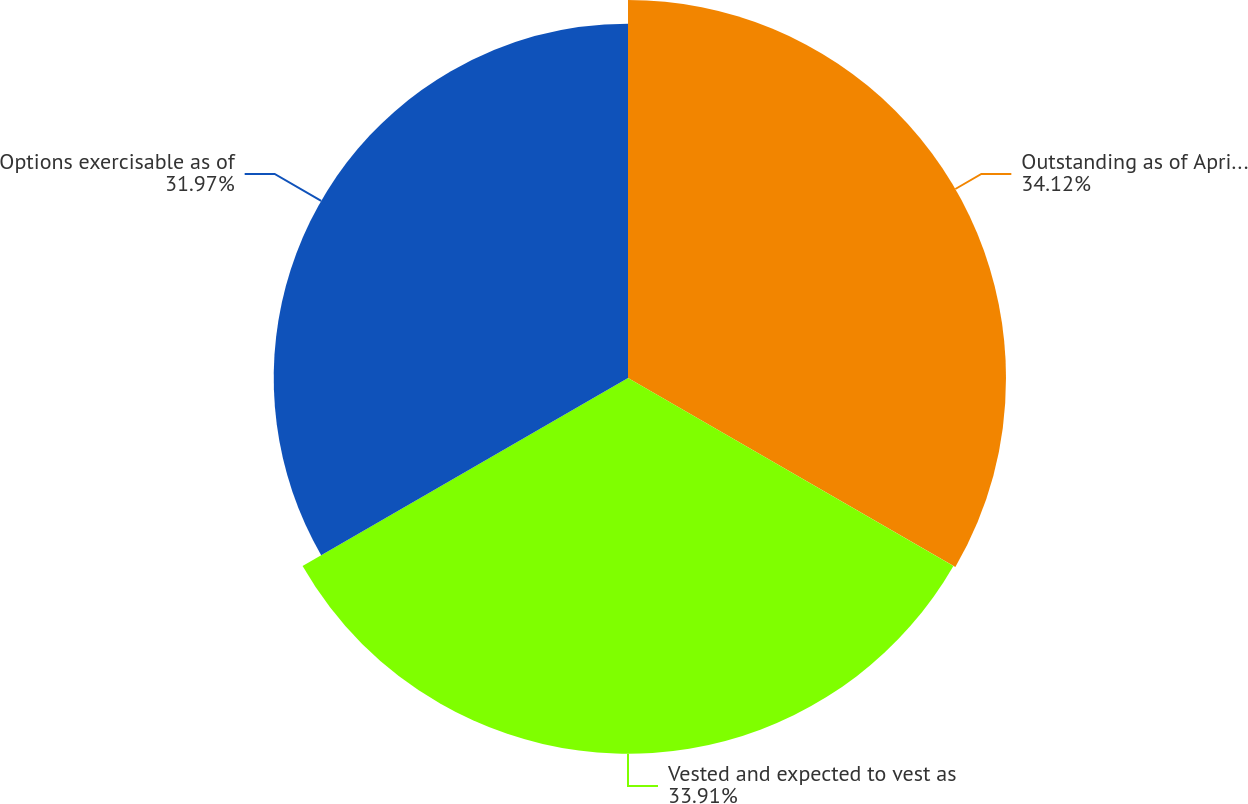Convert chart to OTSL. <chart><loc_0><loc_0><loc_500><loc_500><pie_chart><fcel>Outstanding as of April 2 2016<fcel>Vested and expected to vest as<fcel>Options exercisable as of<nl><fcel>34.11%<fcel>33.91%<fcel>31.97%<nl></chart> 